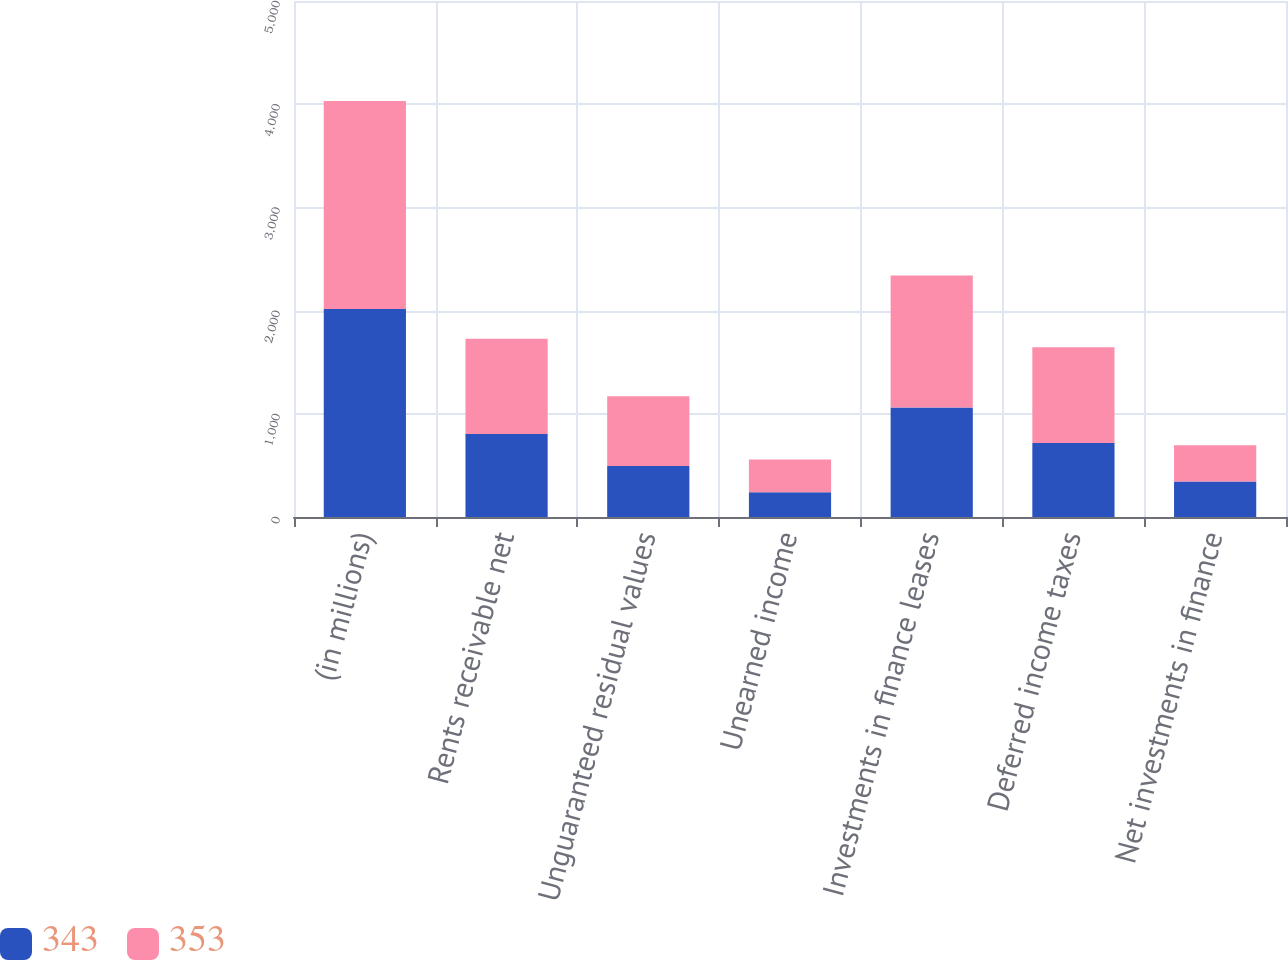<chart> <loc_0><loc_0><loc_500><loc_500><stacked_bar_chart><ecel><fcel>(in millions)<fcel>Rents receivable net<fcel>Unguaranteed residual values<fcel>Unearned income<fcel>Investments in finance leases<fcel>Deferred income taxes<fcel>Net investments in finance<nl><fcel>343<fcel>2016<fcel>805<fcel>495<fcel>240<fcel>1060<fcel>717<fcel>343<nl><fcel>353<fcel>2015<fcel>923<fcel>674<fcel>316<fcel>1281<fcel>928<fcel>353<nl></chart> 